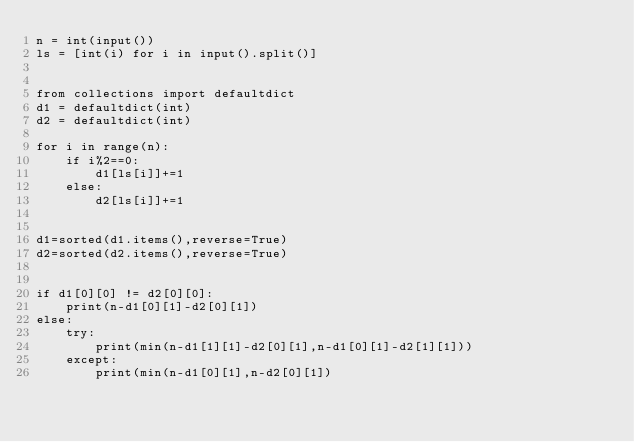<code> <loc_0><loc_0><loc_500><loc_500><_Python_>n = int(input())
ls = [int(i) for i in input().split()]


from collections import defaultdict
d1 = defaultdict(int)
d2 = defaultdict(int)

for i in range(n):
    if i%2==0:
        d1[ls[i]]+=1
    else:
        d2[ls[i]]+=1


d1=sorted(d1.items(),reverse=True)
d2=sorted(d2.items(),reverse=True)


if d1[0][0] != d2[0][0]:
    print(n-d1[0][1]-d2[0][1])
else:
    try:
        print(min(n-d1[1][1]-d2[0][1],n-d1[0][1]-d2[1][1]))
    except:
        print(min(n-d1[0][1],n-d2[0][1])</code> 